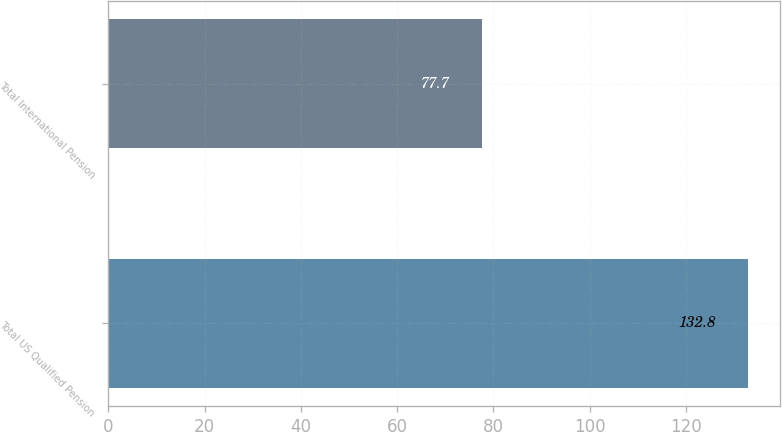Convert chart. <chart><loc_0><loc_0><loc_500><loc_500><bar_chart><fcel>Total US Qualified Pension<fcel>Total International Pension<nl><fcel>132.8<fcel>77.7<nl></chart> 